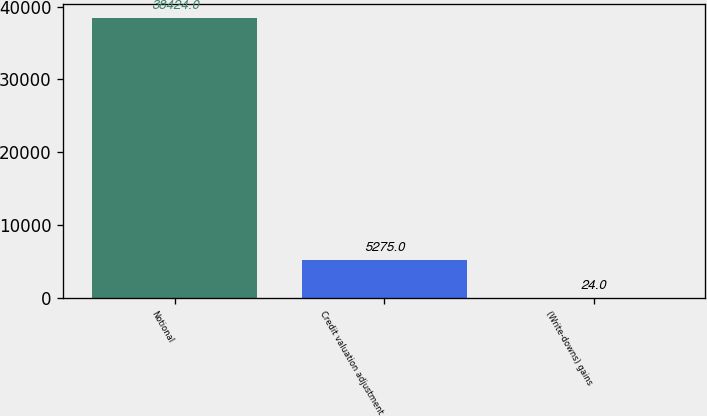Convert chart. <chart><loc_0><loc_0><loc_500><loc_500><bar_chart><fcel>Notional<fcel>Credit valuation adjustment<fcel>(Write-downs) gains<nl><fcel>38424<fcel>5275<fcel>24<nl></chart> 